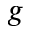<formula> <loc_0><loc_0><loc_500><loc_500>g</formula> 